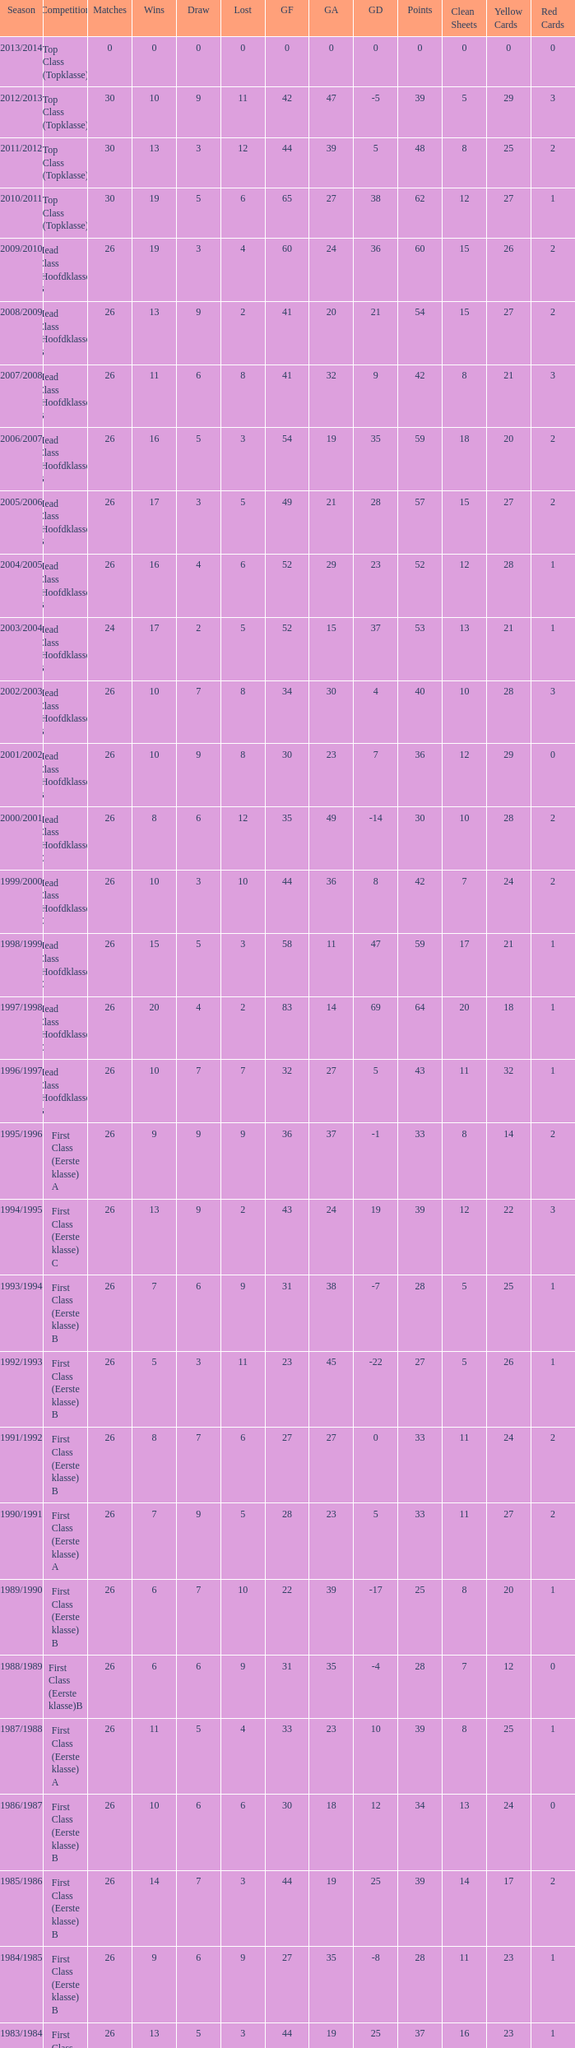What competition has a score greater than 30, a draw less than 5, and a loss larger than 10? Top Class (Topklasse). 